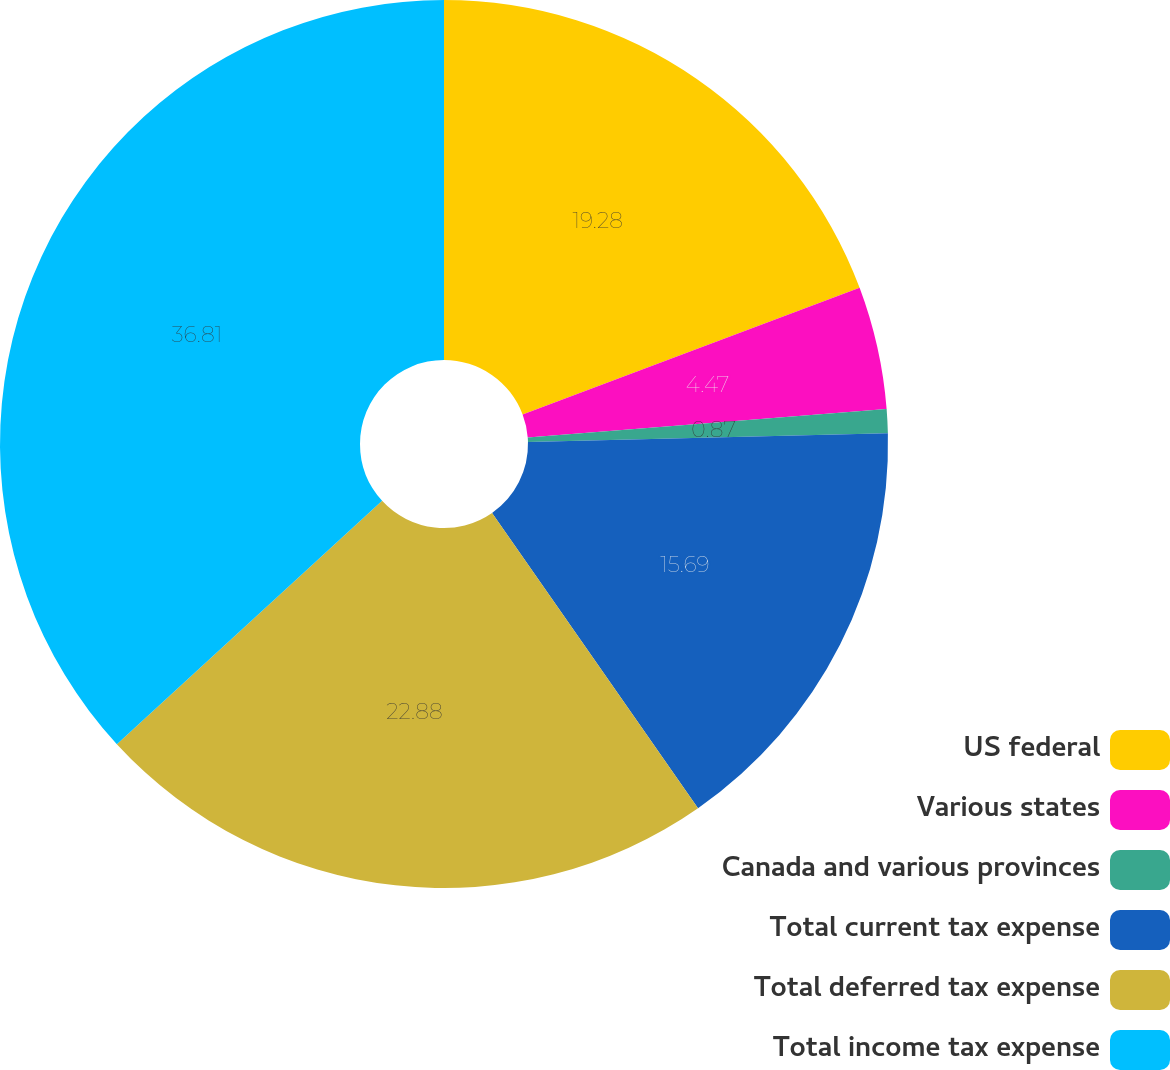<chart> <loc_0><loc_0><loc_500><loc_500><pie_chart><fcel>US federal<fcel>Various states<fcel>Canada and various provinces<fcel>Total current tax expense<fcel>Total deferred tax expense<fcel>Total income tax expense<nl><fcel>19.28%<fcel>4.47%<fcel>0.87%<fcel>15.69%<fcel>22.88%<fcel>36.82%<nl></chart> 